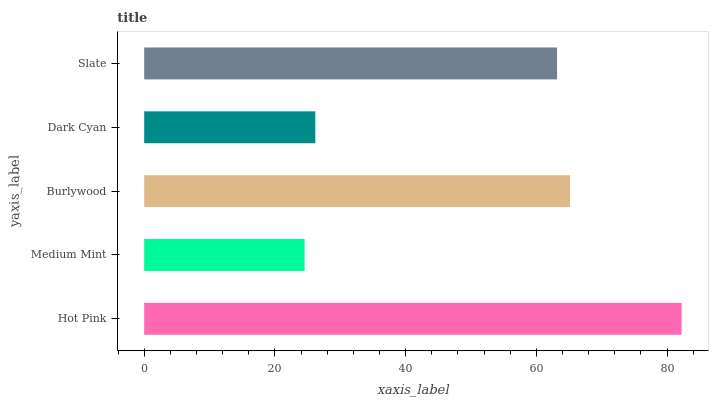Is Medium Mint the minimum?
Answer yes or no. Yes. Is Hot Pink the maximum?
Answer yes or no. Yes. Is Burlywood the minimum?
Answer yes or no. No. Is Burlywood the maximum?
Answer yes or no. No. Is Burlywood greater than Medium Mint?
Answer yes or no. Yes. Is Medium Mint less than Burlywood?
Answer yes or no. Yes. Is Medium Mint greater than Burlywood?
Answer yes or no. No. Is Burlywood less than Medium Mint?
Answer yes or no. No. Is Slate the high median?
Answer yes or no. Yes. Is Slate the low median?
Answer yes or no. Yes. Is Medium Mint the high median?
Answer yes or no. No. Is Medium Mint the low median?
Answer yes or no. No. 